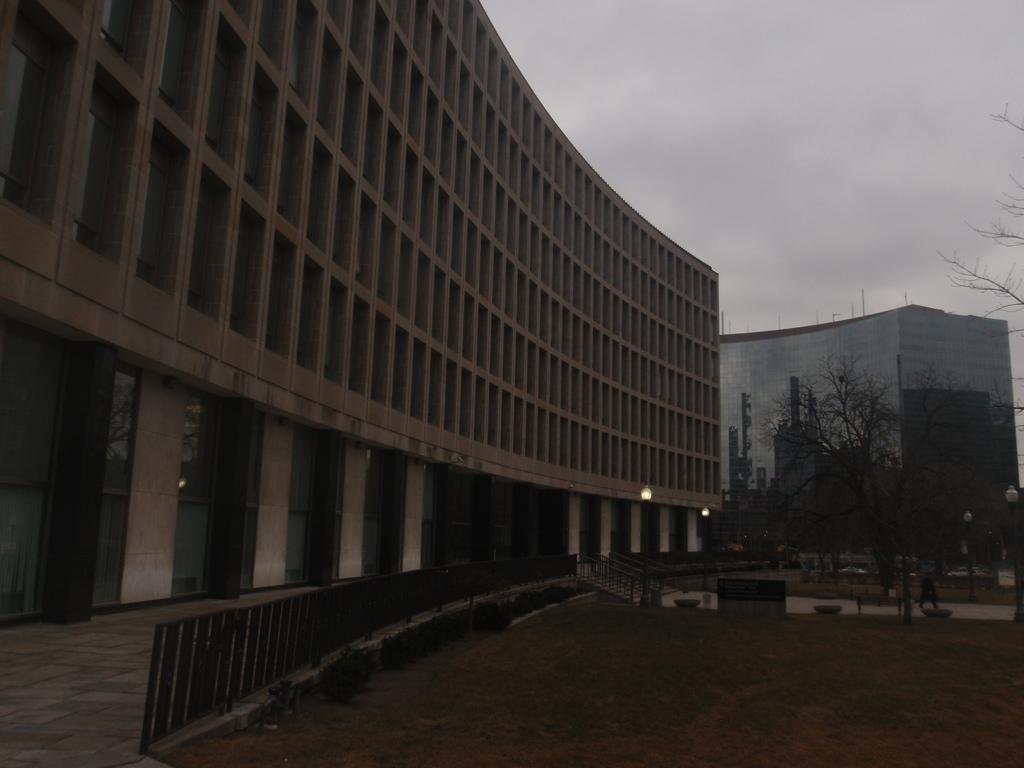What type of natural elements can be seen in the image? There are trees in the image. What type of buildings can be seen in the background? There are cream-colored buildings and a glass building in the background. What is visible in the sky in the image? The sky is visible in the image and appears to be white in color. Can you see a river flowing through the image? There is no river visible in the image. Is there a kitty playing with a fan in the image? There is no kitty or fan present in the image. 